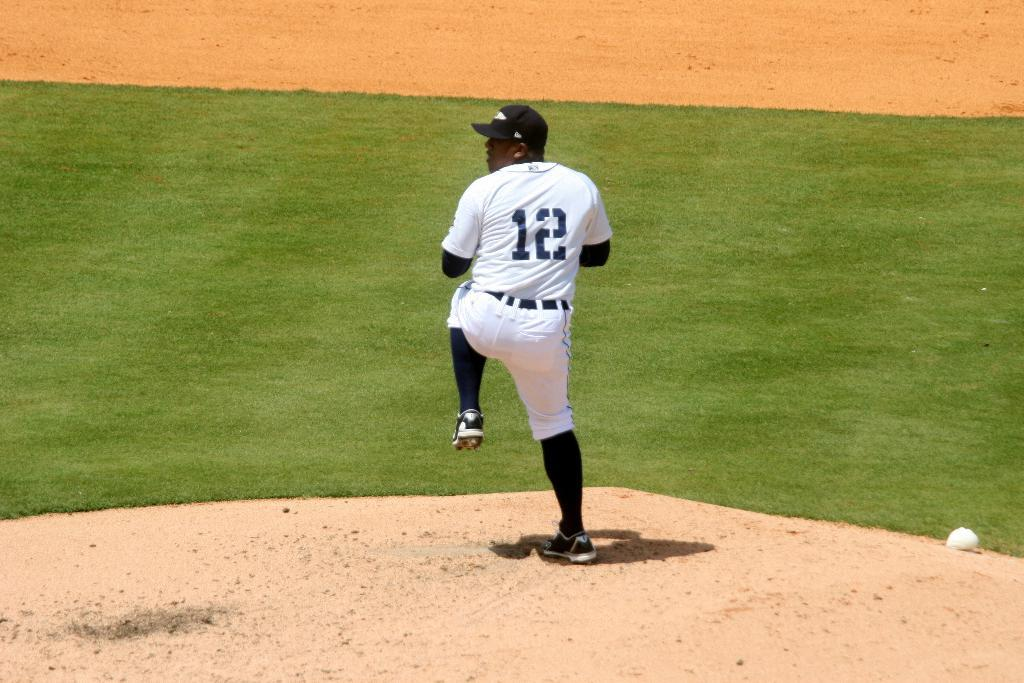Who is present in the image? There is a man in the image. What is the man wearing? The man is wearing a white dress. What is the man's position in relation to the ground? The man is standing on the ground. What direction is the man looking? The man is looking towards the left side. What type of surface is under the man's feet? There is grass on the ground. What kind of location might this image depict? The setting appears to be a playing ground. What type of pan is being used by the man in the image? There is no pan present in the image; the man is wearing a white dress and standing on grass. How many spiders are crawling on the man's dress in the image? There are no spiders visible in the image; the man is wearing a white dress and standing on grass. 